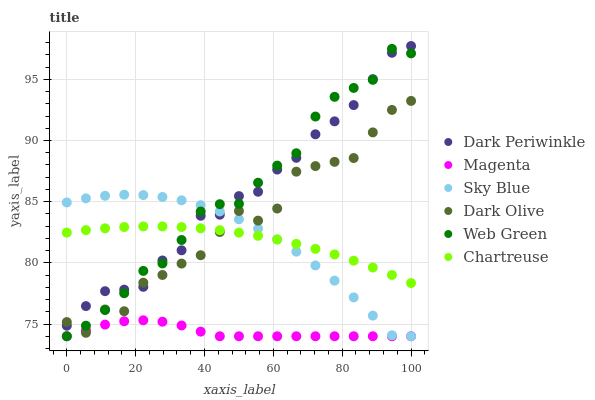Does Magenta have the minimum area under the curve?
Answer yes or no. Yes. Does Web Green have the maximum area under the curve?
Answer yes or no. Yes. Does Chartreuse have the minimum area under the curve?
Answer yes or no. No. Does Chartreuse have the maximum area under the curve?
Answer yes or no. No. Is Chartreuse the smoothest?
Answer yes or no. Yes. Is Dark Olive the roughest?
Answer yes or no. Yes. Is Web Green the smoothest?
Answer yes or no. No. Is Web Green the roughest?
Answer yes or no. No. Does Web Green have the lowest value?
Answer yes or no. Yes. Does Chartreuse have the lowest value?
Answer yes or no. No. Does Dark Periwinkle have the highest value?
Answer yes or no. Yes. Does Web Green have the highest value?
Answer yes or no. No. Is Magenta less than Chartreuse?
Answer yes or no. Yes. Is Dark Periwinkle greater than Magenta?
Answer yes or no. Yes. Does Sky Blue intersect Dark Periwinkle?
Answer yes or no. Yes. Is Sky Blue less than Dark Periwinkle?
Answer yes or no. No. Is Sky Blue greater than Dark Periwinkle?
Answer yes or no. No. Does Magenta intersect Chartreuse?
Answer yes or no. No. 